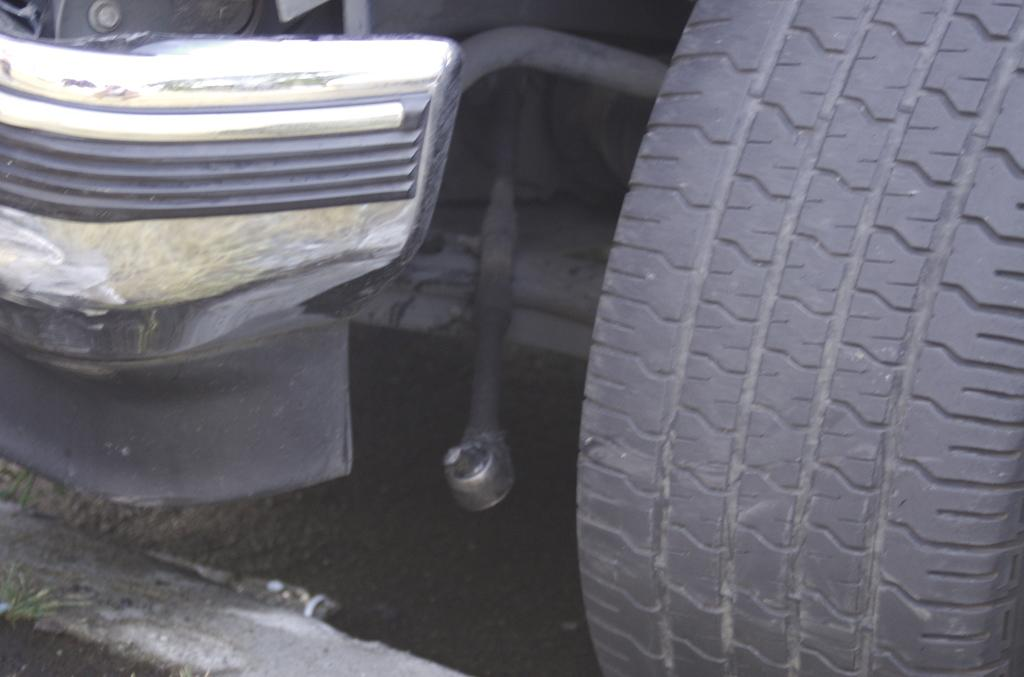What is the main subject in the image? There is a vehicle in the image. Can you describe the position of the vehicle in the image? The vehicle is on the ground. What type of rifle can be seen in the cemetery during winter in the image? There is no rifle, cemetery, or winter scene present in the image; it only features a vehicle on the ground. 